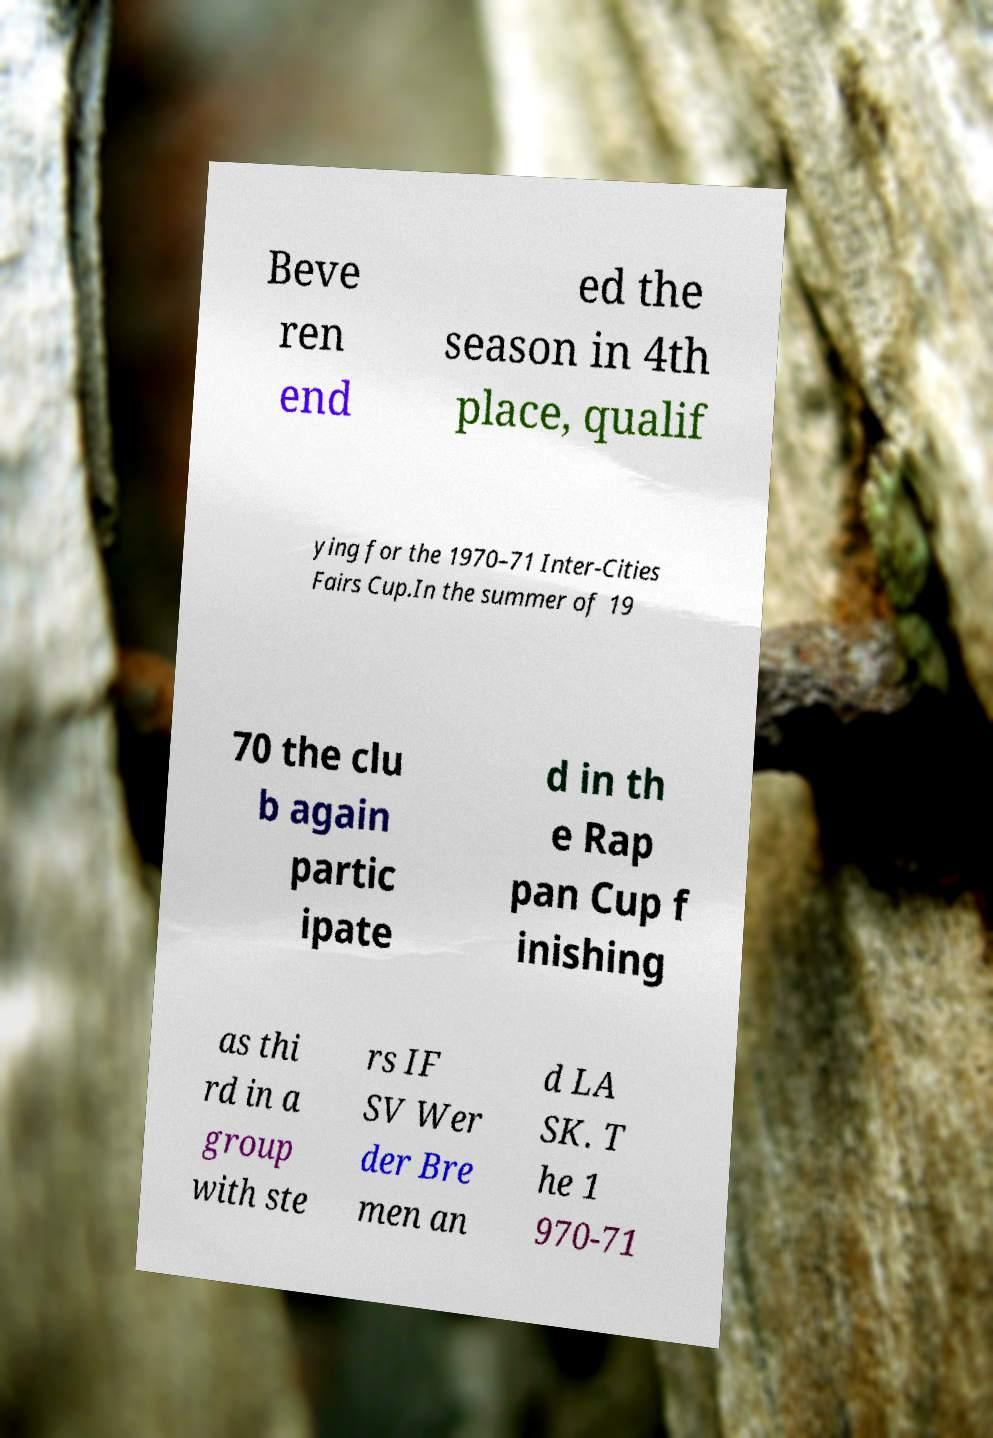What messages or text are displayed in this image? I need them in a readable, typed format. Beve ren end ed the season in 4th place, qualif ying for the 1970–71 Inter-Cities Fairs Cup.In the summer of 19 70 the clu b again partic ipate d in th e Rap pan Cup f inishing as thi rd in a group with ste rs IF SV Wer der Bre men an d LA SK. T he 1 970-71 